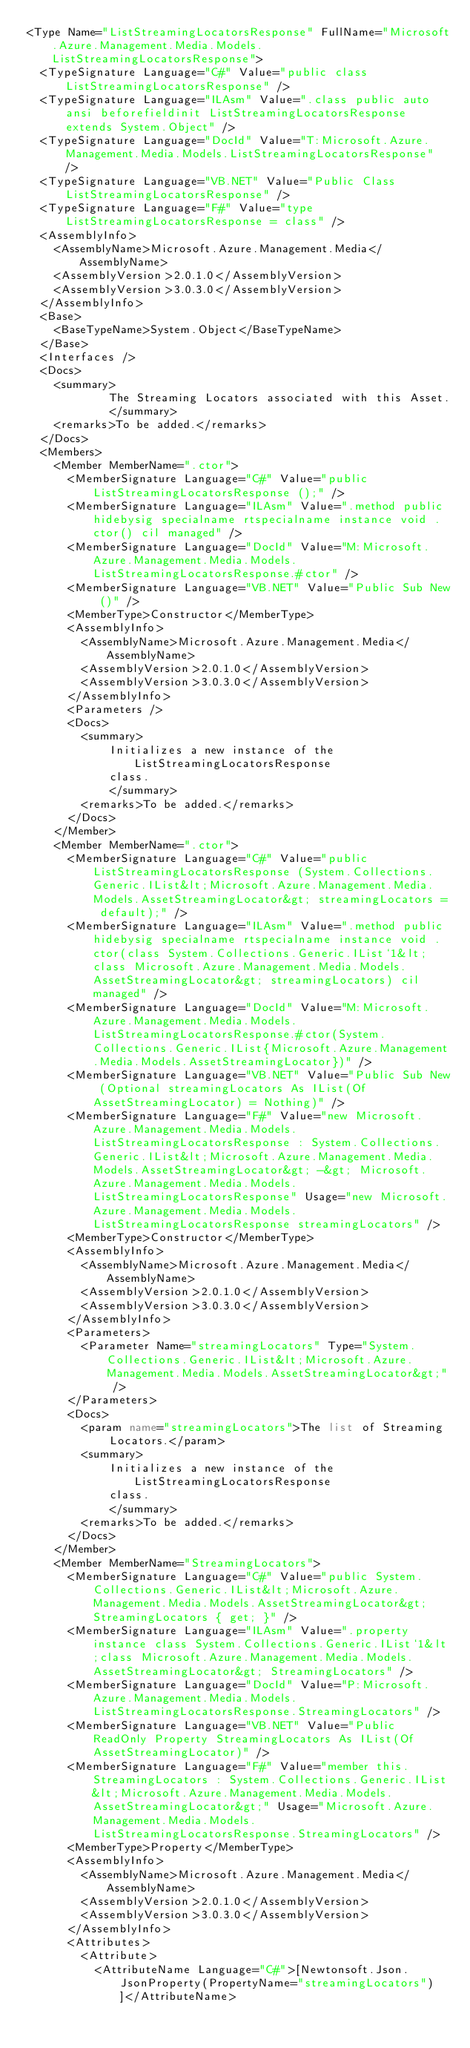Convert code to text. <code><loc_0><loc_0><loc_500><loc_500><_XML_><Type Name="ListStreamingLocatorsResponse" FullName="Microsoft.Azure.Management.Media.Models.ListStreamingLocatorsResponse">
  <TypeSignature Language="C#" Value="public class ListStreamingLocatorsResponse" />
  <TypeSignature Language="ILAsm" Value=".class public auto ansi beforefieldinit ListStreamingLocatorsResponse extends System.Object" />
  <TypeSignature Language="DocId" Value="T:Microsoft.Azure.Management.Media.Models.ListStreamingLocatorsResponse" />
  <TypeSignature Language="VB.NET" Value="Public Class ListStreamingLocatorsResponse" />
  <TypeSignature Language="F#" Value="type ListStreamingLocatorsResponse = class" />
  <AssemblyInfo>
    <AssemblyName>Microsoft.Azure.Management.Media</AssemblyName>
    <AssemblyVersion>2.0.1.0</AssemblyVersion>
    <AssemblyVersion>3.0.3.0</AssemblyVersion>
  </AssemblyInfo>
  <Base>
    <BaseTypeName>System.Object</BaseTypeName>
  </Base>
  <Interfaces />
  <Docs>
    <summary>
            The Streaming Locators associated with this Asset.
            </summary>
    <remarks>To be added.</remarks>
  </Docs>
  <Members>
    <Member MemberName=".ctor">
      <MemberSignature Language="C#" Value="public ListStreamingLocatorsResponse ();" />
      <MemberSignature Language="ILAsm" Value=".method public hidebysig specialname rtspecialname instance void .ctor() cil managed" />
      <MemberSignature Language="DocId" Value="M:Microsoft.Azure.Management.Media.Models.ListStreamingLocatorsResponse.#ctor" />
      <MemberSignature Language="VB.NET" Value="Public Sub New ()" />
      <MemberType>Constructor</MemberType>
      <AssemblyInfo>
        <AssemblyName>Microsoft.Azure.Management.Media</AssemblyName>
        <AssemblyVersion>2.0.1.0</AssemblyVersion>
        <AssemblyVersion>3.0.3.0</AssemblyVersion>
      </AssemblyInfo>
      <Parameters />
      <Docs>
        <summary>
            Initializes a new instance of the ListStreamingLocatorsResponse
            class.
            </summary>
        <remarks>To be added.</remarks>
      </Docs>
    </Member>
    <Member MemberName=".ctor">
      <MemberSignature Language="C#" Value="public ListStreamingLocatorsResponse (System.Collections.Generic.IList&lt;Microsoft.Azure.Management.Media.Models.AssetStreamingLocator&gt; streamingLocators = default);" />
      <MemberSignature Language="ILAsm" Value=".method public hidebysig specialname rtspecialname instance void .ctor(class System.Collections.Generic.IList`1&lt;class Microsoft.Azure.Management.Media.Models.AssetStreamingLocator&gt; streamingLocators) cil managed" />
      <MemberSignature Language="DocId" Value="M:Microsoft.Azure.Management.Media.Models.ListStreamingLocatorsResponse.#ctor(System.Collections.Generic.IList{Microsoft.Azure.Management.Media.Models.AssetStreamingLocator})" />
      <MemberSignature Language="VB.NET" Value="Public Sub New (Optional streamingLocators As IList(Of AssetStreamingLocator) = Nothing)" />
      <MemberSignature Language="F#" Value="new Microsoft.Azure.Management.Media.Models.ListStreamingLocatorsResponse : System.Collections.Generic.IList&lt;Microsoft.Azure.Management.Media.Models.AssetStreamingLocator&gt; -&gt; Microsoft.Azure.Management.Media.Models.ListStreamingLocatorsResponse" Usage="new Microsoft.Azure.Management.Media.Models.ListStreamingLocatorsResponse streamingLocators" />
      <MemberType>Constructor</MemberType>
      <AssemblyInfo>
        <AssemblyName>Microsoft.Azure.Management.Media</AssemblyName>
        <AssemblyVersion>2.0.1.0</AssemblyVersion>
        <AssemblyVersion>3.0.3.0</AssemblyVersion>
      </AssemblyInfo>
      <Parameters>
        <Parameter Name="streamingLocators" Type="System.Collections.Generic.IList&lt;Microsoft.Azure.Management.Media.Models.AssetStreamingLocator&gt;" />
      </Parameters>
      <Docs>
        <param name="streamingLocators">The list of Streaming
            Locators.</param>
        <summary>
            Initializes a new instance of the ListStreamingLocatorsResponse
            class.
            </summary>
        <remarks>To be added.</remarks>
      </Docs>
    </Member>
    <Member MemberName="StreamingLocators">
      <MemberSignature Language="C#" Value="public System.Collections.Generic.IList&lt;Microsoft.Azure.Management.Media.Models.AssetStreamingLocator&gt; StreamingLocators { get; }" />
      <MemberSignature Language="ILAsm" Value=".property instance class System.Collections.Generic.IList`1&lt;class Microsoft.Azure.Management.Media.Models.AssetStreamingLocator&gt; StreamingLocators" />
      <MemberSignature Language="DocId" Value="P:Microsoft.Azure.Management.Media.Models.ListStreamingLocatorsResponse.StreamingLocators" />
      <MemberSignature Language="VB.NET" Value="Public ReadOnly Property StreamingLocators As IList(Of AssetStreamingLocator)" />
      <MemberSignature Language="F#" Value="member this.StreamingLocators : System.Collections.Generic.IList&lt;Microsoft.Azure.Management.Media.Models.AssetStreamingLocator&gt;" Usage="Microsoft.Azure.Management.Media.Models.ListStreamingLocatorsResponse.StreamingLocators" />
      <MemberType>Property</MemberType>
      <AssemblyInfo>
        <AssemblyName>Microsoft.Azure.Management.Media</AssemblyName>
        <AssemblyVersion>2.0.1.0</AssemblyVersion>
        <AssemblyVersion>3.0.3.0</AssemblyVersion>
      </AssemblyInfo>
      <Attributes>
        <Attribute>
          <AttributeName Language="C#">[Newtonsoft.Json.JsonProperty(PropertyName="streamingLocators")]</AttributeName></code> 